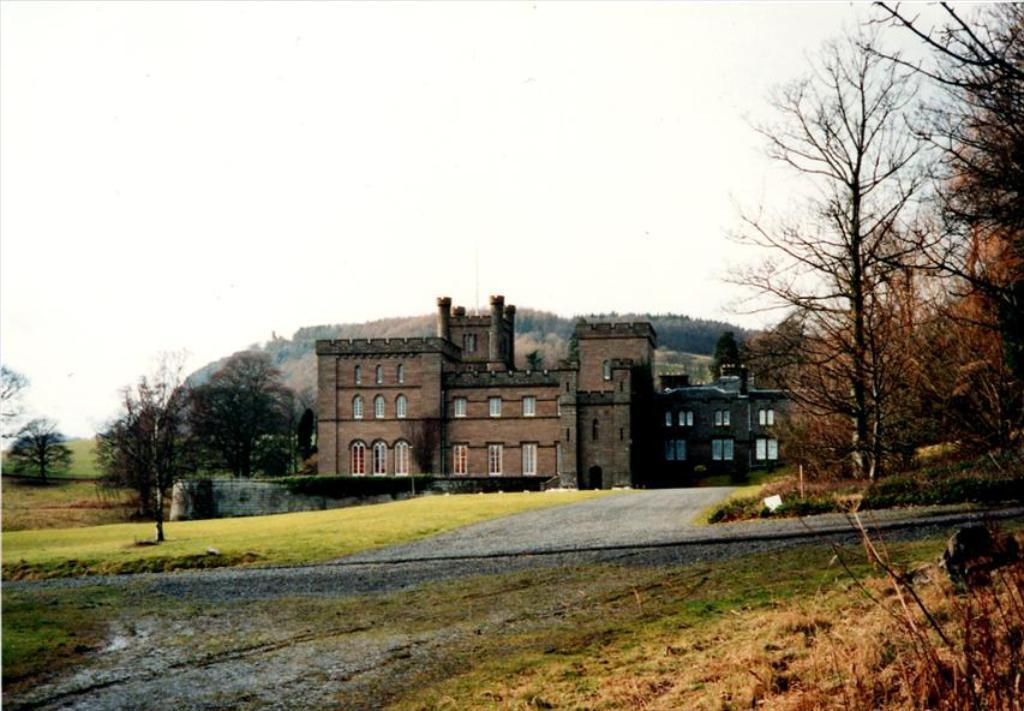What type of vegetation can be seen in the image? There is grass, plants, and trees visible in the image. What type of structures are present in the image? There are buildings in the image. What architectural feature can be seen in the buildings? Windows are visible in the buildings. What natural landmark can be seen in the image? There are mountains in the image. What part of the natural environment is visible in the image? The sky is visible in the image. Can you determine the time of day the image was taken? The image might have been taken during the day, based on the visibility of the sky and the presence of natural light. What type of boundary can be seen in the middle of the image? There is no boundary present in the image; it features grass, plants, trees, buildings, windows, mountains, and the sky. What room is visible in the middle of the image? There is no room visible in the image, as it is an outdoor scene with natural elements and buildings. 